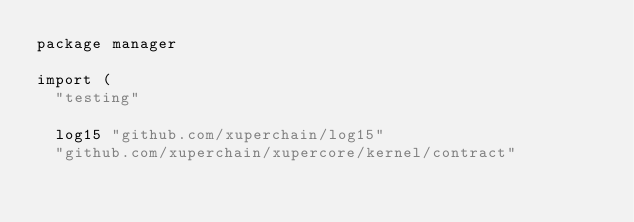Convert code to text. <code><loc_0><loc_0><loc_500><loc_500><_Go_>package manager

import (
	"testing"

	log15 "github.com/xuperchain/log15"
	"github.com/xuperchain/xupercore/kernel/contract"</code> 